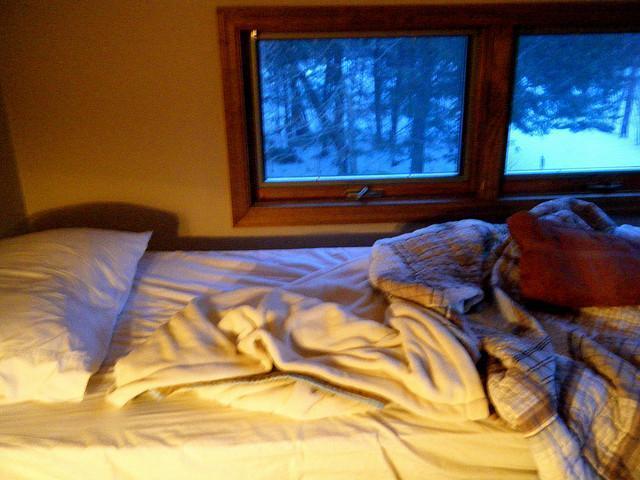How many beds are in the photo?
Give a very brief answer. 1. 